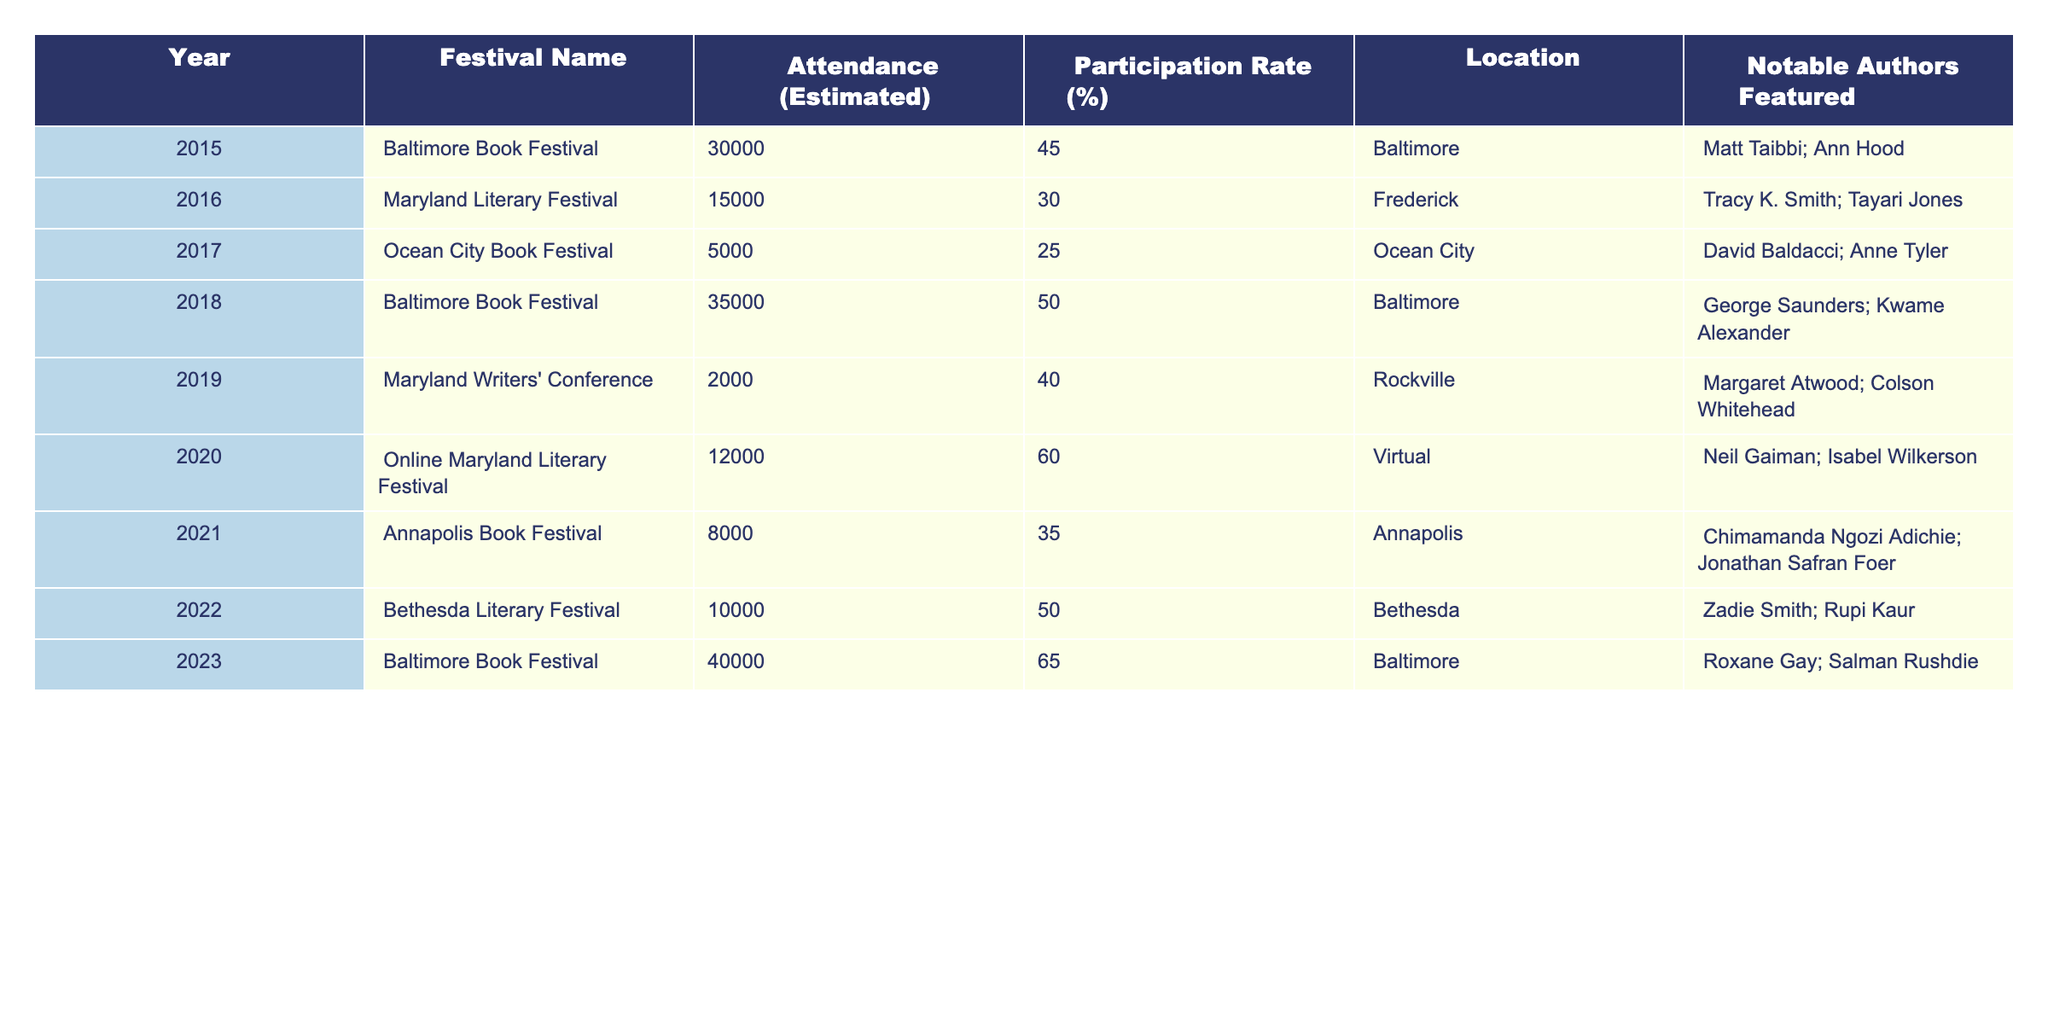What was the maximum attendance recorded at a literary festival in Maryland from 2015 to 2023? By reviewing the attendance figures for each year, the maximum attendance is found in 2023 at the Baltimore Book Festival, with an estimated attendance of 40,000.
Answer: 40,000 Which festival had the lowest participation rate in Maryland between 2015 and 2023? Looking at the participation rates, the Ocean City Book Festival in 2017 had the lowest at 25%.
Answer: 25% What is the average attendance across all festivals listed from 2015 to 2023? Summing up the attendance figures: 30,000 + 15,000 + 5,000 + 35,000 + 2,000 + 12,000 + 8,000 + 10,000 + 40,000 = 162,000. There are 9 festivals, so the average attendance is 162,000 / 9 = 18,000.
Answer: 18,000 Did the participation rate increase from 2020 to 2023? The participation rate in 2020 was 60%, and in 2023, it was 65%. Since 65% is greater than 60%, the participation rate did increase.
Answer: Yes How much did the attendance at the Baltimore Book Festival change from 2015 to 2023? In 2015, the attendance was 30,000, and in 2023, it was 40,000. To find the change, we calculate 40,000 - 30,000 = 10,000, indicating an increase of 10,000 attendees.
Answer: Increase of 10,000 Which notable authors were featured at the Maryland Literary Festival in 2016? The notable authors featured in 2016 at the Maryland Literary Festival were Tracy K. Smith and Tayari Jones, as listed in the table.
Answer: Tracy K. Smith; Tayari Jones What was the change in participation rate from 2019 to 2022? In 2019, the participation rate was 40%, and in 2022, it was 50%. The change is calculated as 50% - 40% = 10%, indicating an increase of 10 percentage points.
Answer: Increase of 10 percentage points Which festival had the highest participation rate in the years presented? Assessing the participation rates, the Baltimore Book Festival in 2023 had the highest percentage at 65%.
Answer: 65% Was there any festival held virtually, and what was its participation rate? Yes, the Online Maryland Literary Festival was held virtually in 2020, and it had a participation rate of 60%.
Answer: Yes, 60% How many total notable authors were featured at the festivals in 2017? In 2017 (Ocean City Book Festival), two notable authors were featured: David Baldacci and Anne Tyler, totaling to 2 authors.
Answer: 2 